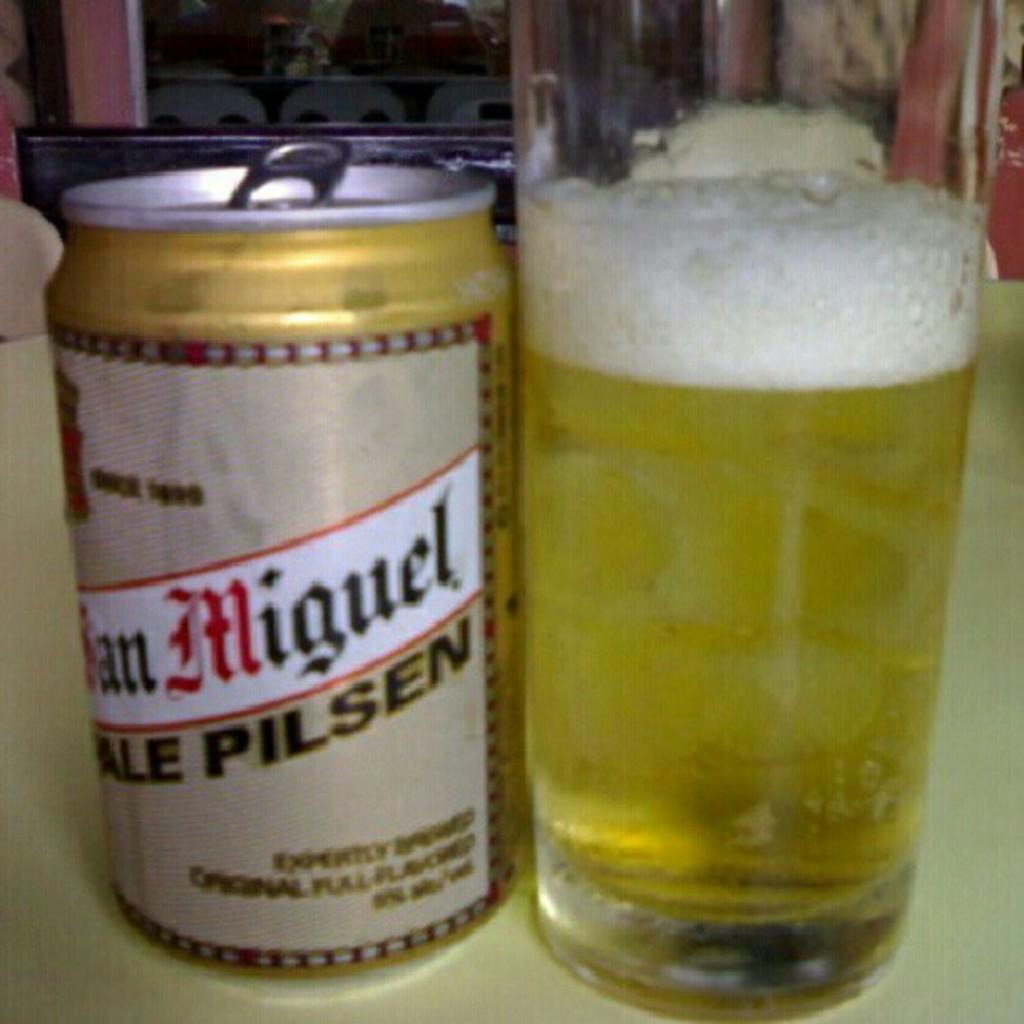What brand is the left beer?
Your response must be concise. San miguel. 